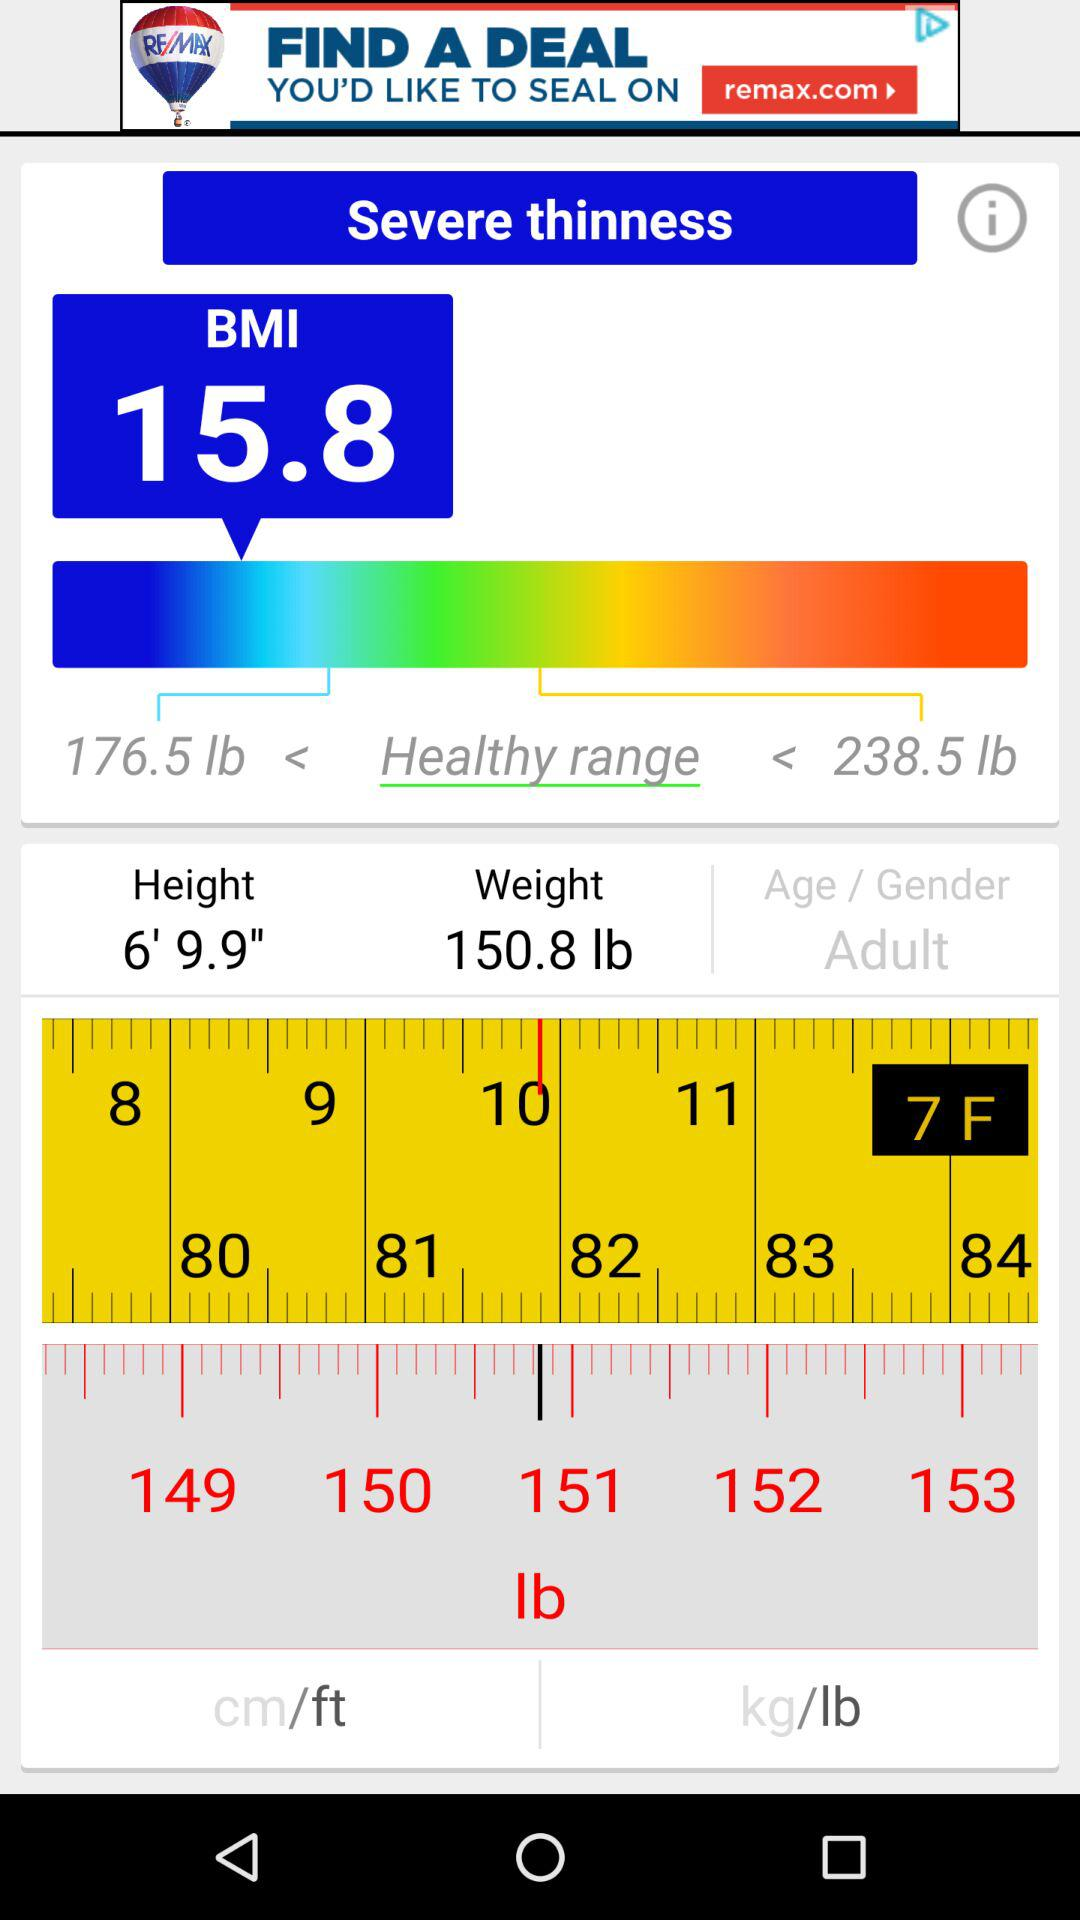What is the selected height? The selected height is 6'9.9". 